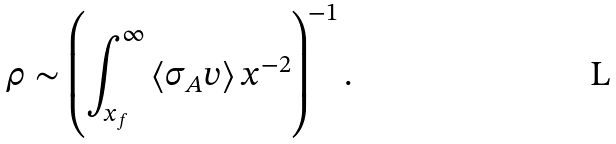<formula> <loc_0><loc_0><loc_500><loc_500>\rho \sim \left ( \int _ { x _ { f } } ^ { \infty } \left < \sigma _ { A } v \right > x ^ { - 2 } \right ) ^ { - 1 } .</formula> 